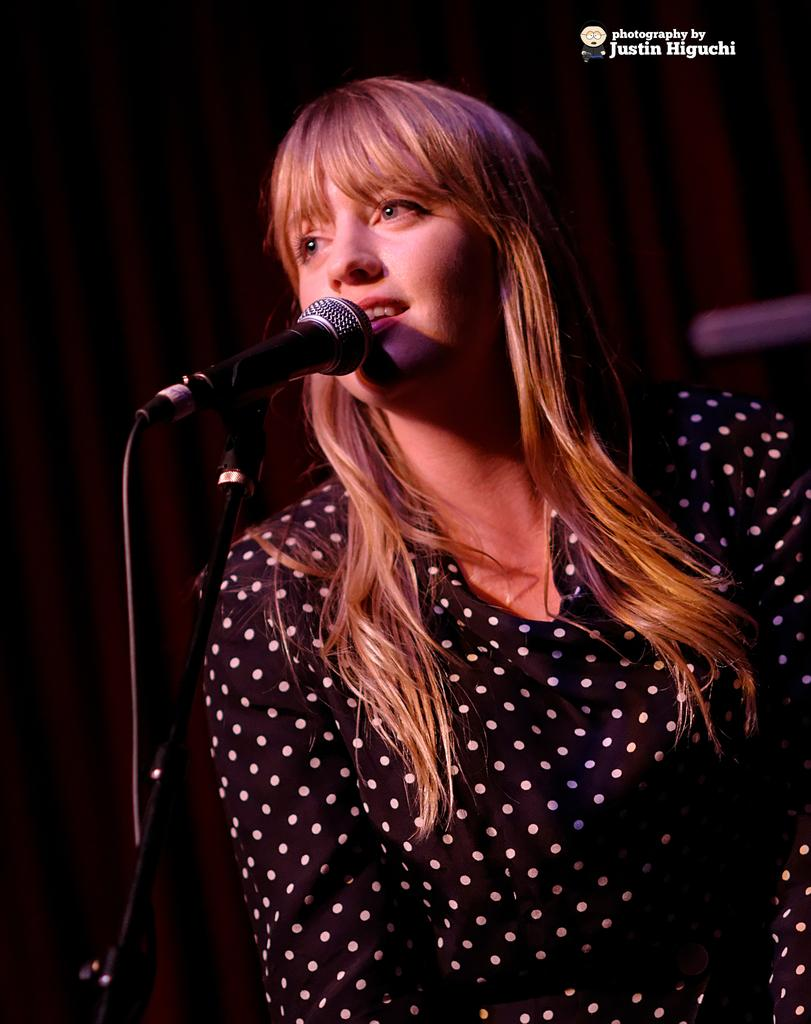Who is the main subject in the image? There is a woman in the image. What object is visible in the image that is typically used for amplifying sound? There is a mic in the image. Can you describe any additional features or elements in the image? There is a watermark on the right side of the image. What type of pencil is the representative holding in the image? There is no representative or pencil present in the image. What is the purpose of the hall in the image? There is no hall present in the image. 